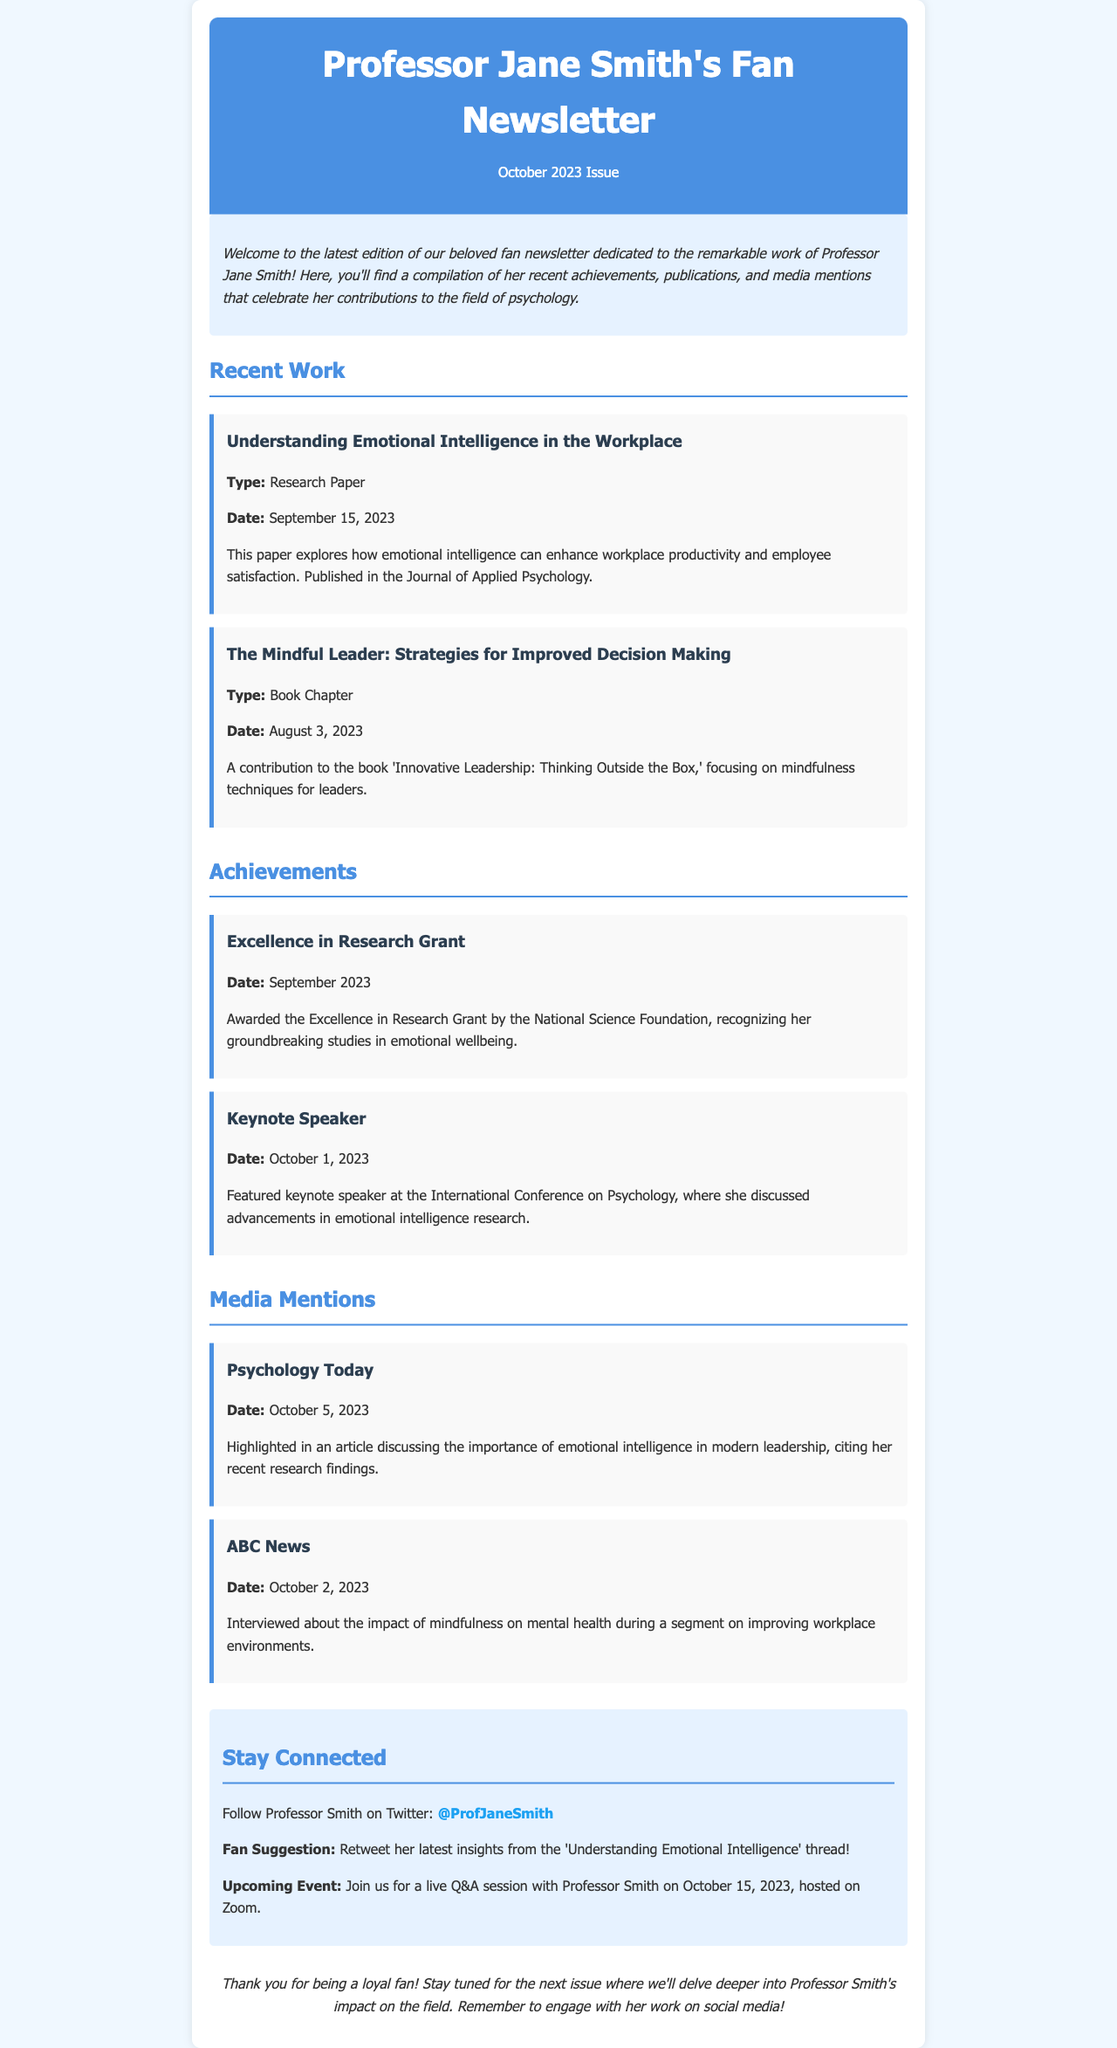What is the title of the recent research paper? The title is found in the Recent Work section of the newsletter.
Answer: Understanding Emotional Intelligence in the Workplace When was the book chapter published? The publication date is listed in the Recent Work section.
Answer: August 3, 2023 Who awarded the Excellence in Research Grant? The awarding body is mentioned under Achievements.
Answer: National Science Foundation What date is the live Q&A session scheduled for? This information is specified in the social media section.
Answer: October 15, 2023 What publication featured an article about emotional intelligence? The media mention section identifies where this is mentioned.
Answer: Psychology Today How many notable mentions are listed under Media Mentions? The count can be derived from the list in the section.
Answer: Two What is the primary focus of the recent research paper? The focus is summarized in the description of the work item.
Answer: Workplace productivity and employee satisfaction Which event did Professor Smith speak at in October 2023? The event is described in the Achievements section.
Answer: International Conference on Psychology 